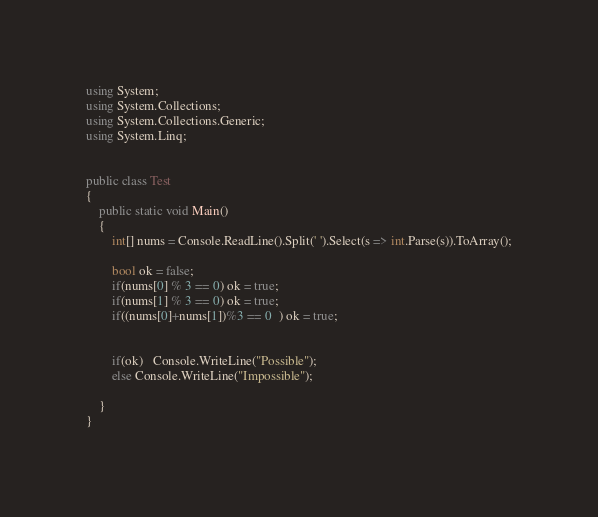Convert code to text. <code><loc_0><loc_0><loc_500><loc_500><_C#_>using System;
using System.Collections;
using System.Collections.Generic;
using System.Linq;


public class Test
{	
    public static void Main()
	{
	    int[] nums = Console.ReadLine().Split(' ').Select(s => int.Parse(s)).ToArray();

        bool ok = false;
        if(nums[0] % 3 == 0) ok = true;
        if(nums[1] % 3 == 0) ok = true;
        if((nums[0]+nums[1])%3 == 0  ) ok = true;
        
        
        if(ok)   Console.WriteLine("Possible");
        else Console.WriteLine("Impossible");
        
	}
}</code> 